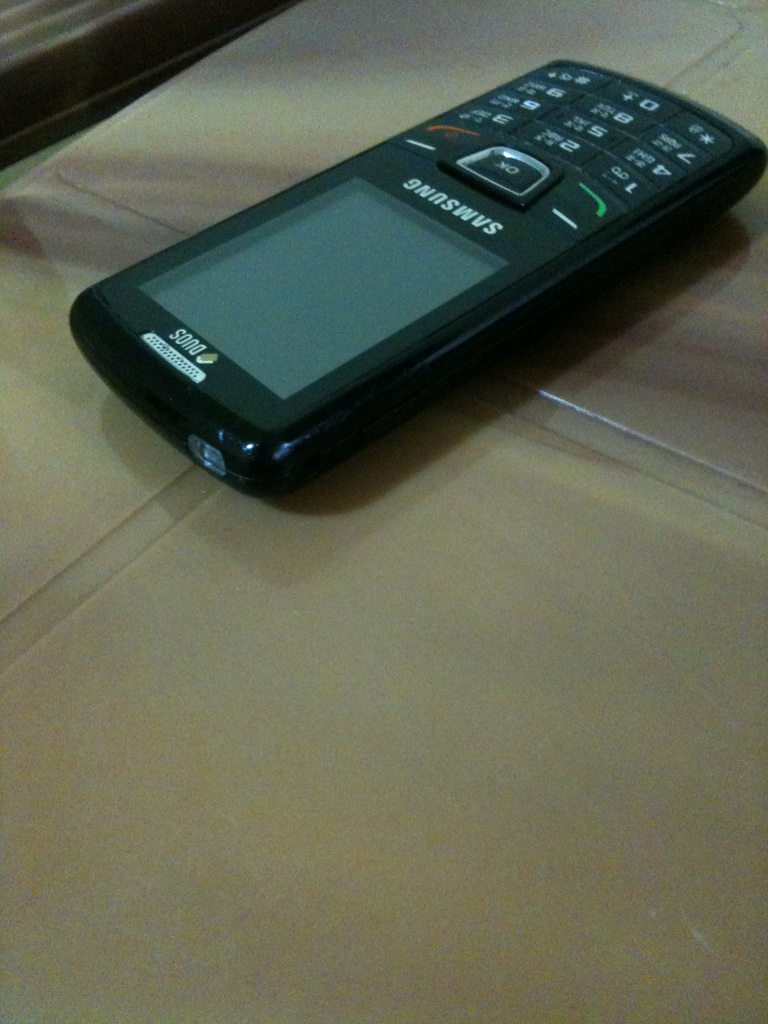What is this? What is this? from Vizwiz cell phone 